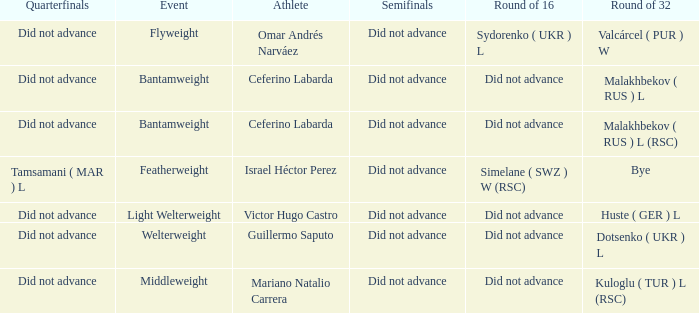When there was a bye in the round of 32, what was the result in the round of 16? Did not advance. 